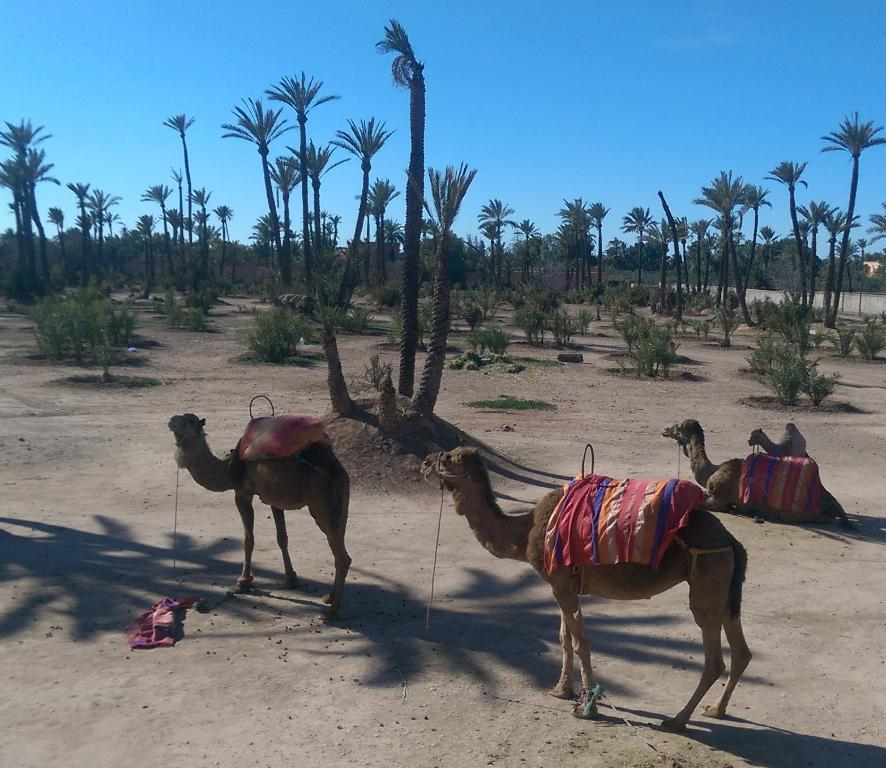What type of animals can be seen in the image? There are camels in the image. What other living organisms are present in the image? There are plants and trees in the image. What is the man-made structure visible in the image? There is a wall in the image. What part of the natural environment is visible in the image? The sky is visible in the background of the image. What type of collar can be seen on the camels in the image? There are no collars visible on the camels in the image. What is the camels doing with the wax in the image? There is no wax present in the image, and the camels are not performing any actions with it. 